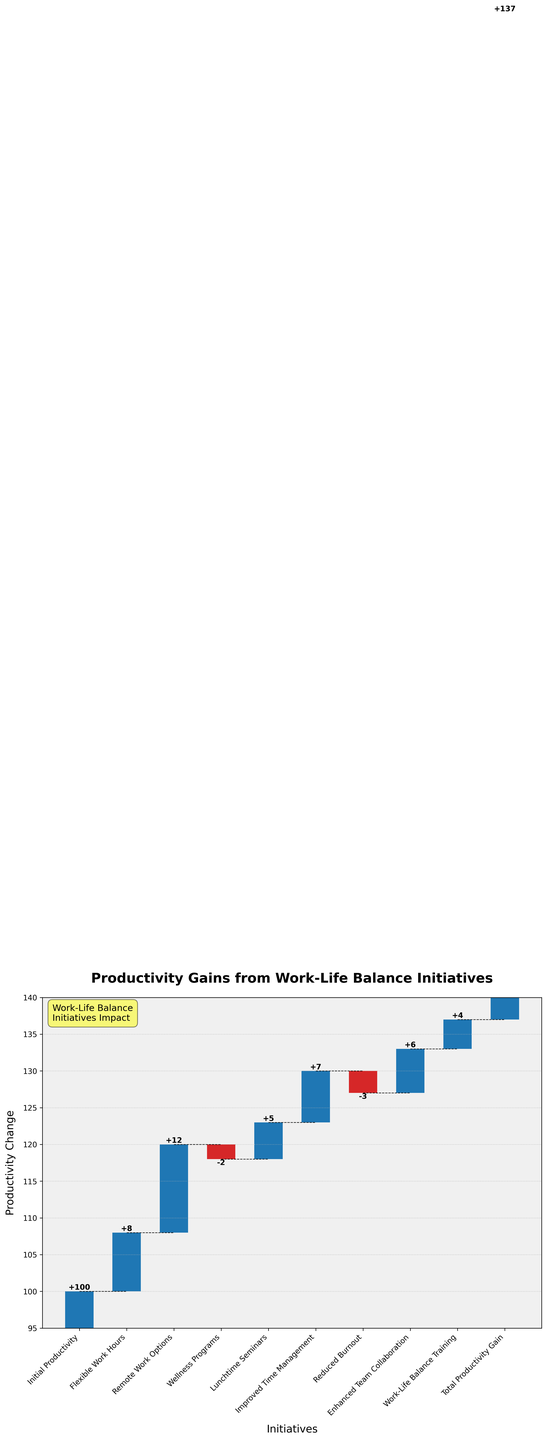What is the title of this chart? The title is displayed at the top of the chart in bold. It indicates the focus of the visual representation.
Answer: Productivity Gains from Work-Life Balance Initiatives Which initiative contributed the most to productivity? By observing the chart, the largest positive bar represents the highest contribution.
Answer: Remote Work Options How did the Wellness Programs affect productivity? Wellness Programs generated a negative bar, indicating a drop in productivity.
Answer: Decreased productivity by 2 units What is the cumulative productivity gain after introducing Flexible Work Hours? At the point right after Flexible Work Hours, check the stacked and connected value.
Answer: 108 units How does the productivity gain from Improved Time Management compare to that from Flexible Work Hours? Compare the heights of the bars corresponding to these two initiatives.
Answer: Improved Time Management (+7 units) is higher by 1 unit than Flexible Work Hours (+8 units) What is the net change in productivity after Lunchtime Seminars? Sum up the productivity changes from the initiatives before it and add the value of Lunchtime Seminars.
Answer: 123 units How many initiatives had a positive impact on productivity? Count the number of positive bars above the baseline in the chart.
Answer: Seven initiatives What would be the productivity if there were no negative impacts from initiatives? Add the positive impacts and ignore any negative impacts (Wellness Programs and Reduced Burnout).
Answer: 149 units What is the increase in productivity specifically due to the Lunchtime Seminars? Look at the bar corresponding to Lunchtime Seminars.
Answer: 5 units How does Reduced Burnout compare to the overall productivity gain? Compare the contribution of Reduced Burnout to the total productivity gain represented by the final bar.
Answer: Reduced productivity by 3 units while the overall gain is 137 units 